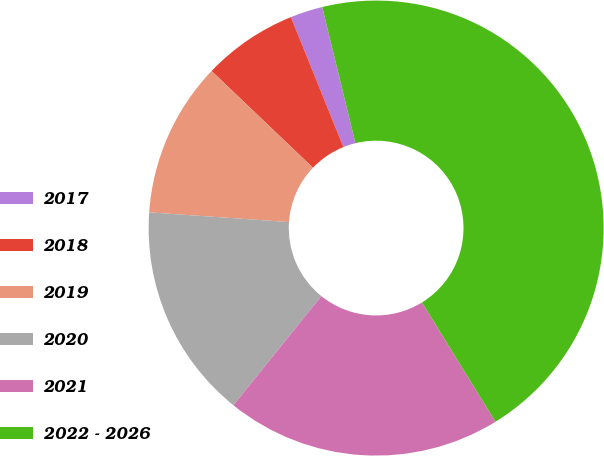Convert chart to OTSL. <chart><loc_0><loc_0><loc_500><loc_500><pie_chart><fcel>2017<fcel>2018<fcel>2019<fcel>2020<fcel>2021<fcel>2022 - 2026<nl><fcel>2.3%<fcel>6.76%<fcel>11.03%<fcel>15.31%<fcel>19.58%<fcel>45.03%<nl></chart> 